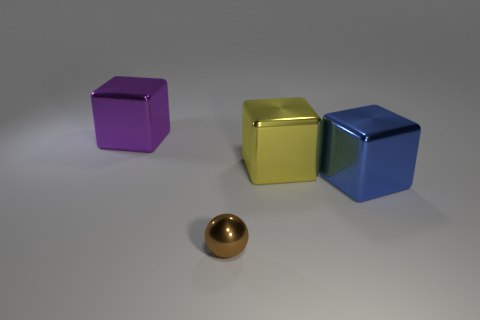Are there an equal number of brown balls behind the large purple metallic cube and brown shiny things behind the tiny brown shiny thing?
Make the answer very short. Yes. What number of other objects are the same color as the tiny thing?
Keep it short and to the point. 0. Is the number of yellow blocks in front of the yellow block the same as the number of large cyan metallic blocks?
Your answer should be compact. Yes. Does the sphere have the same size as the purple object?
Keep it short and to the point. No. There is a thing that is both left of the yellow block and in front of the big purple cube; what material is it?
Your answer should be compact. Metal. What number of blue metallic things are the same shape as the purple shiny thing?
Offer a terse response. 1. What is the material of the block to the left of the tiny metallic object?
Provide a succinct answer. Metal. Are there fewer small brown shiny things that are behind the purple thing than green objects?
Ensure brevity in your answer.  No. Is the shape of the yellow object the same as the small thing?
Your answer should be very brief. No. Is there any other thing that has the same shape as the small brown shiny thing?
Ensure brevity in your answer.  No. 